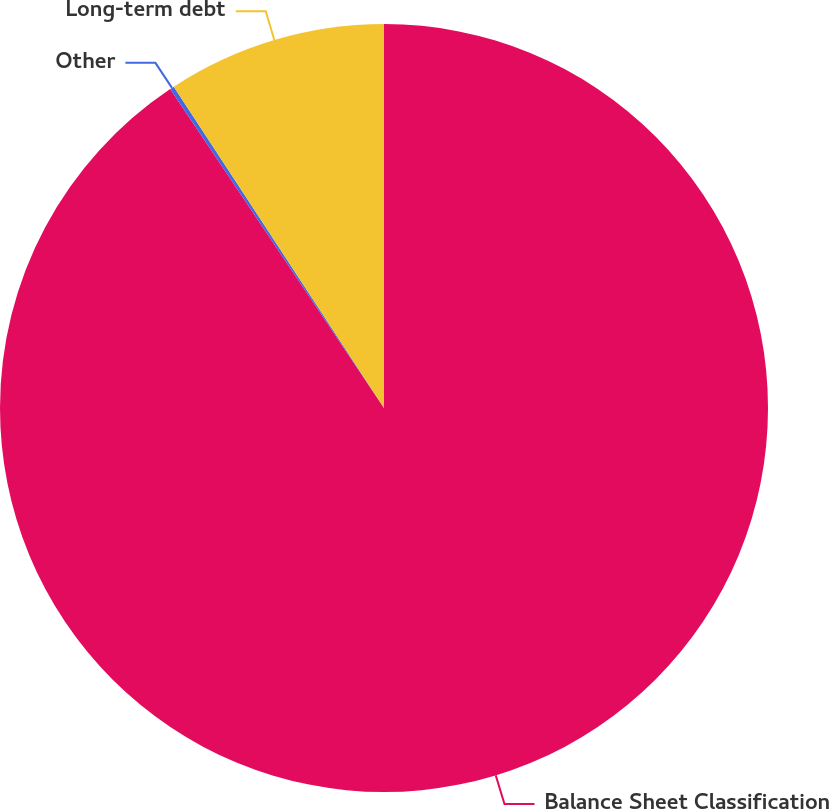Convert chart. <chart><loc_0><loc_0><loc_500><loc_500><pie_chart><fcel>Balance Sheet Classification<fcel>Other<fcel>Long-term debt<nl><fcel>90.6%<fcel>0.18%<fcel>9.22%<nl></chart> 